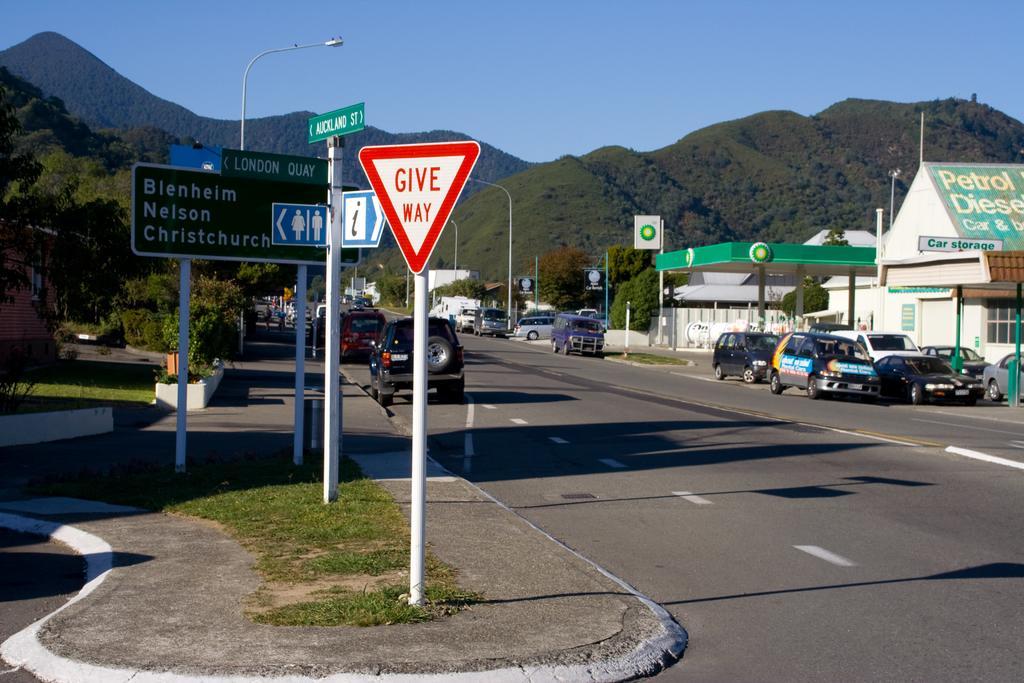Could you give a brief overview of what you see in this image? In this image we can see some vehicles on the road, there are some houses, poles, signboards, plants, trees and mountains, in the background we can see the sky. 